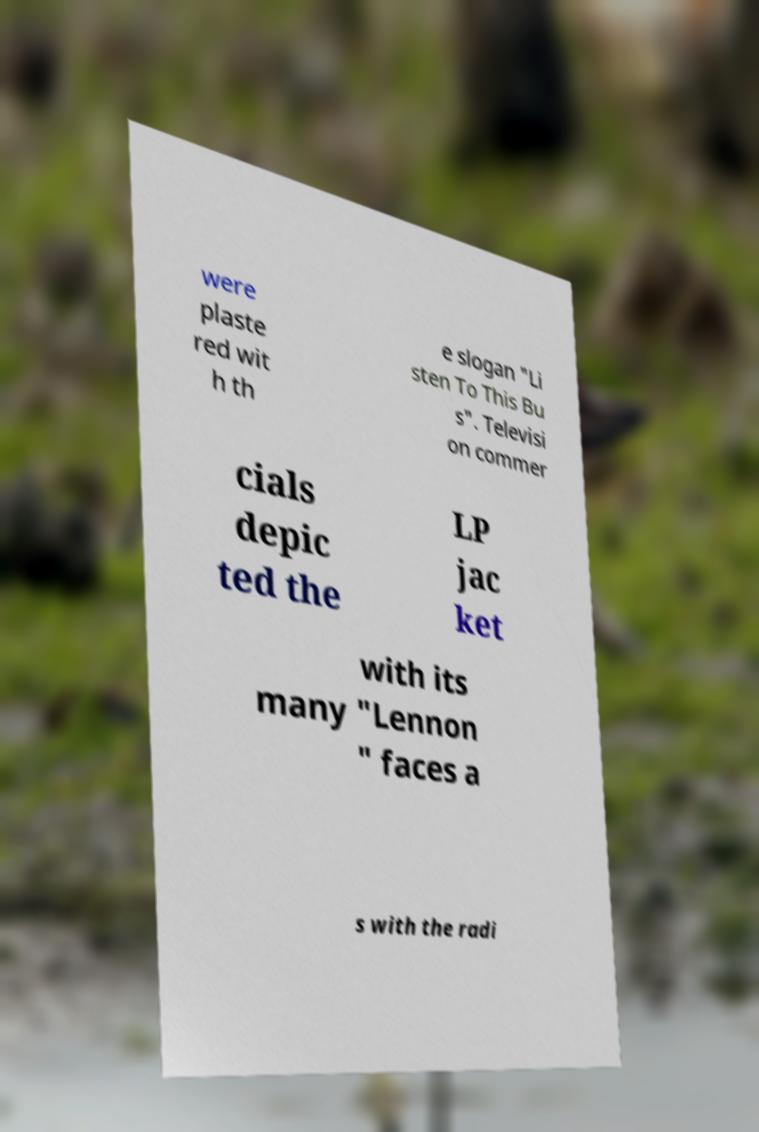Please read and relay the text visible in this image. What does it say? were plaste red wit h th e slogan "Li sten To This Bu s". Televisi on commer cials depic ted the LP jac ket with its many "Lennon " faces a s with the radi 